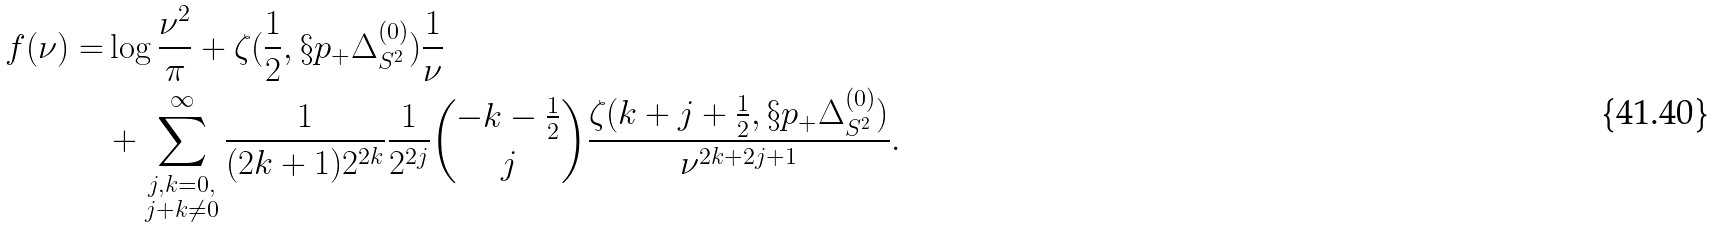Convert formula to latex. <formula><loc_0><loc_0><loc_500><loc_500>f ( \nu ) = & \log \frac { \nu ^ { 2 } } { \pi } + \zeta ( \frac { 1 } { 2 } , \S p _ { + } \Delta ^ { ( 0 ) } _ { S ^ { 2 } } ) \frac { 1 } { \nu } \\ & + \sum _ { \substack { j , k = 0 , \\ j + k \not = 0 } } ^ { \infty } \frac { 1 } { ( 2 k + 1 ) 2 ^ { 2 k } } \frac { 1 } { 2 ^ { 2 j } } \binom { - k - \frac { 1 } { 2 } } { j } \frac { \zeta ( k + j + \frac { 1 } { 2 } , \S p _ { + } \Delta ^ { ( 0 ) } _ { S ^ { 2 } } ) } { \nu ^ { 2 k + 2 j + 1 } } .</formula> 